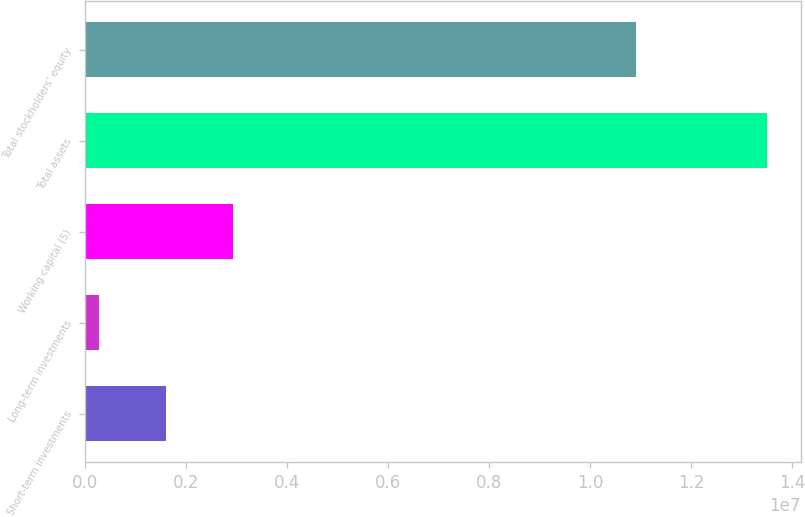Convert chart to OTSL. <chart><loc_0><loc_0><loc_500><loc_500><bar_chart><fcel>Short-term investments<fcel>Long-term investments<fcel>Working capital (5)<fcel>Total assets<fcel>Total stockholders' equity<nl><fcel>1.59947e+06<fcel>277853<fcel>2.92108e+06<fcel>1.3494e+07<fcel>1.09046e+07<nl></chart> 